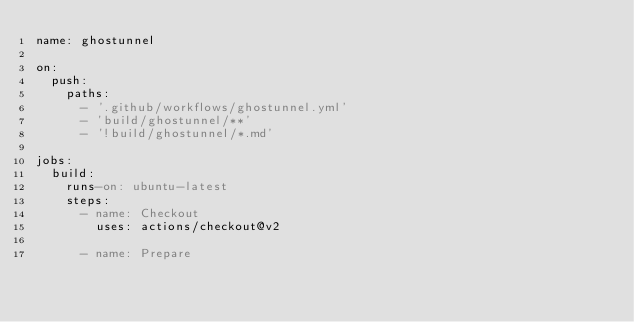<code> <loc_0><loc_0><loc_500><loc_500><_YAML_>name: ghostunnel

on:
  push:
    paths:
      - '.github/workflows/ghostunnel.yml'
      - 'build/ghostunnel/**'
      - '!build/ghostunnel/*.md'

jobs:
  build:
    runs-on: ubuntu-latest
    steps:
      - name: Checkout
        uses: actions/checkout@v2

      - name: Prepare</code> 